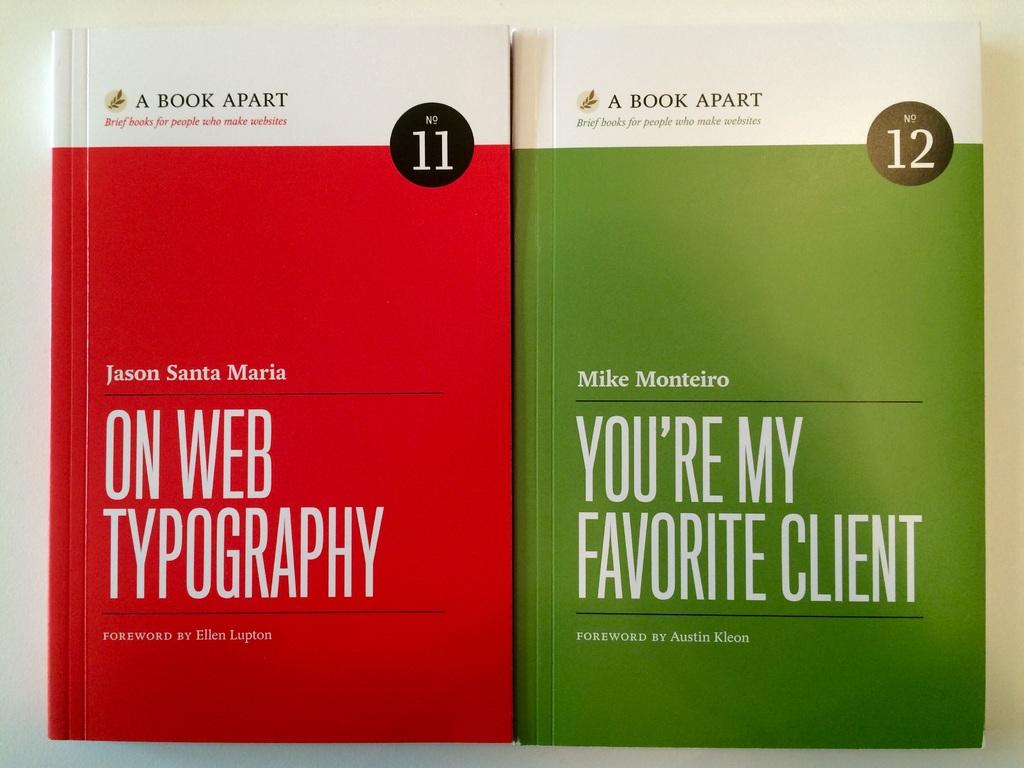What volume is the mostly red book?
Offer a terse response. 11. 